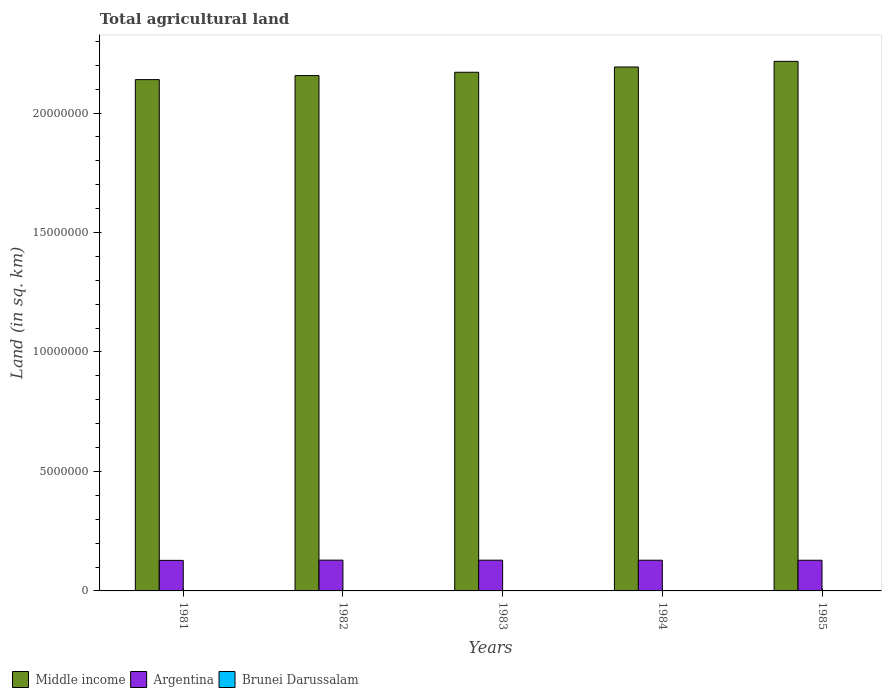How many groups of bars are there?
Offer a very short reply. 5. How many bars are there on the 5th tick from the left?
Ensure brevity in your answer.  3. In how many cases, is the number of bars for a given year not equal to the number of legend labels?
Give a very brief answer. 0. What is the total agricultural land in Argentina in 1985?
Offer a terse response. 1.28e+06. Across all years, what is the maximum total agricultural land in Middle income?
Your answer should be very brief. 2.22e+07. Across all years, what is the minimum total agricultural land in Middle income?
Make the answer very short. 2.14e+07. What is the total total agricultural land in Middle income in the graph?
Ensure brevity in your answer.  1.09e+08. What is the difference between the total agricultural land in Brunei Darussalam in 1982 and that in 1984?
Make the answer very short. 10. What is the difference between the total agricultural land in Argentina in 1982 and the total agricultural land in Brunei Darussalam in 1985?
Your answer should be very brief. 1.29e+06. What is the average total agricultural land in Argentina per year?
Provide a succinct answer. 1.28e+06. In the year 1984, what is the difference between the total agricultural land in Middle income and total agricultural land in Brunei Darussalam?
Offer a terse response. 2.19e+07. Is the total agricultural land in Argentina in 1981 less than that in 1984?
Your answer should be very brief. Yes. What is the difference between the highest and the second highest total agricultural land in Brunei Darussalam?
Offer a terse response. 10. What is the difference between the highest and the lowest total agricultural land in Brunei Darussalam?
Give a very brief answer. 20. In how many years, is the total agricultural land in Middle income greater than the average total agricultural land in Middle income taken over all years?
Give a very brief answer. 2. What does the 2nd bar from the left in 1985 represents?
Make the answer very short. Argentina. Is it the case that in every year, the sum of the total agricultural land in Middle income and total agricultural land in Brunei Darussalam is greater than the total agricultural land in Argentina?
Your response must be concise. Yes. Are all the bars in the graph horizontal?
Ensure brevity in your answer.  No. What is the difference between two consecutive major ticks on the Y-axis?
Provide a short and direct response. 5.00e+06. Are the values on the major ticks of Y-axis written in scientific E-notation?
Offer a very short reply. No. Where does the legend appear in the graph?
Keep it short and to the point. Bottom left. What is the title of the graph?
Provide a succinct answer. Total agricultural land. Does "Paraguay" appear as one of the legend labels in the graph?
Your answer should be compact. No. What is the label or title of the X-axis?
Your response must be concise. Years. What is the label or title of the Y-axis?
Offer a very short reply. Land (in sq. km). What is the Land (in sq. km) in Middle income in 1981?
Your answer should be compact. 2.14e+07. What is the Land (in sq. km) of Argentina in 1981?
Provide a succinct answer. 1.28e+06. What is the Land (in sq. km) in Brunei Darussalam in 1981?
Your response must be concise. 140. What is the Land (in sq. km) of Middle income in 1982?
Your answer should be compact. 2.16e+07. What is the Land (in sq. km) of Argentina in 1982?
Your answer should be compact. 1.29e+06. What is the Land (in sq. km) of Brunei Darussalam in 1982?
Ensure brevity in your answer.  130. What is the Land (in sq. km) of Middle income in 1983?
Offer a terse response. 2.17e+07. What is the Land (in sq. km) in Argentina in 1983?
Provide a short and direct response. 1.29e+06. What is the Land (in sq. km) in Brunei Darussalam in 1983?
Provide a succinct answer. 130. What is the Land (in sq. km) in Middle income in 1984?
Provide a succinct answer. 2.19e+07. What is the Land (in sq. km) in Argentina in 1984?
Your response must be concise. 1.29e+06. What is the Land (in sq. km) in Brunei Darussalam in 1984?
Keep it short and to the point. 120. What is the Land (in sq. km) of Middle income in 1985?
Provide a succinct answer. 2.22e+07. What is the Land (in sq. km) of Argentina in 1985?
Your response must be concise. 1.28e+06. What is the Land (in sq. km) in Brunei Darussalam in 1985?
Ensure brevity in your answer.  120. Across all years, what is the maximum Land (in sq. km) of Middle income?
Offer a very short reply. 2.22e+07. Across all years, what is the maximum Land (in sq. km) of Argentina?
Provide a succinct answer. 1.29e+06. Across all years, what is the maximum Land (in sq. km) of Brunei Darussalam?
Keep it short and to the point. 140. Across all years, what is the minimum Land (in sq. km) in Middle income?
Your response must be concise. 2.14e+07. Across all years, what is the minimum Land (in sq. km) of Argentina?
Provide a succinct answer. 1.28e+06. Across all years, what is the minimum Land (in sq. km) in Brunei Darussalam?
Your response must be concise. 120. What is the total Land (in sq. km) in Middle income in the graph?
Your response must be concise. 1.09e+08. What is the total Land (in sq. km) in Argentina in the graph?
Your answer should be compact. 6.42e+06. What is the total Land (in sq. km) in Brunei Darussalam in the graph?
Provide a succinct answer. 640. What is the difference between the Land (in sq. km) in Middle income in 1981 and that in 1982?
Your answer should be compact. -1.69e+05. What is the difference between the Land (in sq. km) of Argentina in 1981 and that in 1982?
Offer a terse response. -8750. What is the difference between the Land (in sq. km) in Middle income in 1981 and that in 1983?
Provide a succinct answer. -3.08e+05. What is the difference between the Land (in sq. km) in Argentina in 1981 and that in 1983?
Make the answer very short. -7500. What is the difference between the Land (in sq. km) of Brunei Darussalam in 1981 and that in 1983?
Your answer should be very brief. 10. What is the difference between the Land (in sq. km) of Middle income in 1981 and that in 1984?
Your answer should be very brief. -5.28e+05. What is the difference between the Land (in sq. km) of Argentina in 1981 and that in 1984?
Provide a succinct answer. -6230. What is the difference between the Land (in sq. km) of Brunei Darussalam in 1981 and that in 1984?
Give a very brief answer. 20. What is the difference between the Land (in sq. km) of Middle income in 1981 and that in 1985?
Keep it short and to the point. -7.64e+05. What is the difference between the Land (in sq. km) in Argentina in 1981 and that in 1985?
Ensure brevity in your answer.  -4970. What is the difference between the Land (in sq. km) in Brunei Darussalam in 1981 and that in 1985?
Keep it short and to the point. 20. What is the difference between the Land (in sq. km) in Middle income in 1982 and that in 1983?
Your answer should be very brief. -1.39e+05. What is the difference between the Land (in sq. km) of Argentina in 1982 and that in 1983?
Your answer should be compact. 1250. What is the difference between the Land (in sq. km) in Middle income in 1982 and that in 1984?
Provide a succinct answer. -3.59e+05. What is the difference between the Land (in sq. km) in Argentina in 1982 and that in 1984?
Offer a very short reply. 2520. What is the difference between the Land (in sq. km) of Brunei Darussalam in 1982 and that in 1984?
Your response must be concise. 10. What is the difference between the Land (in sq. km) of Middle income in 1982 and that in 1985?
Give a very brief answer. -5.96e+05. What is the difference between the Land (in sq. km) of Argentina in 1982 and that in 1985?
Offer a terse response. 3780. What is the difference between the Land (in sq. km) of Middle income in 1983 and that in 1984?
Provide a short and direct response. -2.20e+05. What is the difference between the Land (in sq. km) in Argentina in 1983 and that in 1984?
Offer a terse response. 1270. What is the difference between the Land (in sq. km) of Middle income in 1983 and that in 1985?
Ensure brevity in your answer.  -4.56e+05. What is the difference between the Land (in sq. km) of Argentina in 1983 and that in 1985?
Offer a terse response. 2530. What is the difference between the Land (in sq. km) of Middle income in 1984 and that in 1985?
Your response must be concise. -2.36e+05. What is the difference between the Land (in sq. km) in Argentina in 1984 and that in 1985?
Provide a succinct answer. 1260. What is the difference between the Land (in sq. km) of Middle income in 1981 and the Land (in sq. km) of Argentina in 1982?
Provide a succinct answer. 2.01e+07. What is the difference between the Land (in sq. km) in Middle income in 1981 and the Land (in sq. km) in Brunei Darussalam in 1982?
Keep it short and to the point. 2.14e+07. What is the difference between the Land (in sq. km) of Argentina in 1981 and the Land (in sq. km) of Brunei Darussalam in 1982?
Your response must be concise. 1.28e+06. What is the difference between the Land (in sq. km) in Middle income in 1981 and the Land (in sq. km) in Argentina in 1983?
Your response must be concise. 2.01e+07. What is the difference between the Land (in sq. km) of Middle income in 1981 and the Land (in sq. km) of Brunei Darussalam in 1983?
Ensure brevity in your answer.  2.14e+07. What is the difference between the Land (in sq. km) in Argentina in 1981 and the Land (in sq. km) in Brunei Darussalam in 1983?
Offer a terse response. 1.28e+06. What is the difference between the Land (in sq. km) of Middle income in 1981 and the Land (in sq. km) of Argentina in 1984?
Your answer should be very brief. 2.01e+07. What is the difference between the Land (in sq. km) of Middle income in 1981 and the Land (in sq. km) of Brunei Darussalam in 1984?
Ensure brevity in your answer.  2.14e+07. What is the difference between the Land (in sq. km) of Argentina in 1981 and the Land (in sq. km) of Brunei Darussalam in 1984?
Ensure brevity in your answer.  1.28e+06. What is the difference between the Land (in sq. km) in Middle income in 1981 and the Land (in sq. km) in Argentina in 1985?
Give a very brief answer. 2.01e+07. What is the difference between the Land (in sq. km) of Middle income in 1981 and the Land (in sq. km) of Brunei Darussalam in 1985?
Offer a very short reply. 2.14e+07. What is the difference between the Land (in sq. km) in Argentina in 1981 and the Land (in sq. km) in Brunei Darussalam in 1985?
Keep it short and to the point. 1.28e+06. What is the difference between the Land (in sq. km) of Middle income in 1982 and the Land (in sq. km) of Argentina in 1983?
Provide a succinct answer. 2.03e+07. What is the difference between the Land (in sq. km) of Middle income in 1982 and the Land (in sq. km) of Brunei Darussalam in 1983?
Your response must be concise. 2.16e+07. What is the difference between the Land (in sq. km) of Argentina in 1982 and the Land (in sq. km) of Brunei Darussalam in 1983?
Provide a short and direct response. 1.29e+06. What is the difference between the Land (in sq. km) of Middle income in 1982 and the Land (in sq. km) of Argentina in 1984?
Ensure brevity in your answer.  2.03e+07. What is the difference between the Land (in sq. km) of Middle income in 1982 and the Land (in sq. km) of Brunei Darussalam in 1984?
Provide a short and direct response. 2.16e+07. What is the difference between the Land (in sq. km) in Argentina in 1982 and the Land (in sq. km) in Brunei Darussalam in 1984?
Offer a very short reply. 1.29e+06. What is the difference between the Land (in sq. km) of Middle income in 1982 and the Land (in sq. km) of Argentina in 1985?
Make the answer very short. 2.03e+07. What is the difference between the Land (in sq. km) in Middle income in 1982 and the Land (in sq. km) in Brunei Darussalam in 1985?
Provide a succinct answer. 2.16e+07. What is the difference between the Land (in sq. km) of Argentina in 1982 and the Land (in sq. km) of Brunei Darussalam in 1985?
Offer a terse response. 1.29e+06. What is the difference between the Land (in sq. km) of Middle income in 1983 and the Land (in sq. km) of Argentina in 1984?
Provide a succinct answer. 2.04e+07. What is the difference between the Land (in sq. km) of Middle income in 1983 and the Land (in sq. km) of Brunei Darussalam in 1984?
Ensure brevity in your answer.  2.17e+07. What is the difference between the Land (in sq. km) of Argentina in 1983 and the Land (in sq. km) of Brunei Darussalam in 1984?
Provide a short and direct response. 1.29e+06. What is the difference between the Land (in sq. km) in Middle income in 1983 and the Land (in sq. km) in Argentina in 1985?
Your response must be concise. 2.04e+07. What is the difference between the Land (in sq. km) in Middle income in 1983 and the Land (in sq. km) in Brunei Darussalam in 1985?
Your answer should be very brief. 2.17e+07. What is the difference between the Land (in sq. km) in Argentina in 1983 and the Land (in sq. km) in Brunei Darussalam in 1985?
Keep it short and to the point. 1.29e+06. What is the difference between the Land (in sq. km) in Middle income in 1984 and the Land (in sq. km) in Argentina in 1985?
Make the answer very short. 2.06e+07. What is the difference between the Land (in sq. km) in Middle income in 1984 and the Land (in sq. km) in Brunei Darussalam in 1985?
Your response must be concise. 2.19e+07. What is the difference between the Land (in sq. km) of Argentina in 1984 and the Land (in sq. km) of Brunei Darussalam in 1985?
Your answer should be very brief. 1.29e+06. What is the average Land (in sq. km) in Middle income per year?
Provide a short and direct response. 2.18e+07. What is the average Land (in sq. km) of Argentina per year?
Ensure brevity in your answer.  1.28e+06. What is the average Land (in sq. km) in Brunei Darussalam per year?
Offer a very short reply. 128. In the year 1981, what is the difference between the Land (in sq. km) of Middle income and Land (in sq. km) of Argentina?
Provide a short and direct response. 2.01e+07. In the year 1981, what is the difference between the Land (in sq. km) of Middle income and Land (in sq. km) of Brunei Darussalam?
Your response must be concise. 2.14e+07. In the year 1981, what is the difference between the Land (in sq. km) of Argentina and Land (in sq. km) of Brunei Darussalam?
Offer a very short reply. 1.28e+06. In the year 1982, what is the difference between the Land (in sq. km) in Middle income and Land (in sq. km) in Argentina?
Your answer should be compact. 2.03e+07. In the year 1982, what is the difference between the Land (in sq. km) in Middle income and Land (in sq. km) in Brunei Darussalam?
Provide a short and direct response. 2.16e+07. In the year 1982, what is the difference between the Land (in sq. km) of Argentina and Land (in sq. km) of Brunei Darussalam?
Offer a very short reply. 1.29e+06. In the year 1983, what is the difference between the Land (in sq. km) of Middle income and Land (in sq. km) of Argentina?
Ensure brevity in your answer.  2.04e+07. In the year 1983, what is the difference between the Land (in sq. km) of Middle income and Land (in sq. km) of Brunei Darussalam?
Make the answer very short. 2.17e+07. In the year 1983, what is the difference between the Land (in sq. km) of Argentina and Land (in sq. km) of Brunei Darussalam?
Provide a short and direct response. 1.29e+06. In the year 1984, what is the difference between the Land (in sq. km) of Middle income and Land (in sq. km) of Argentina?
Your response must be concise. 2.06e+07. In the year 1984, what is the difference between the Land (in sq. km) in Middle income and Land (in sq. km) in Brunei Darussalam?
Your answer should be compact. 2.19e+07. In the year 1984, what is the difference between the Land (in sq. km) of Argentina and Land (in sq. km) of Brunei Darussalam?
Ensure brevity in your answer.  1.29e+06. In the year 1985, what is the difference between the Land (in sq. km) in Middle income and Land (in sq. km) in Argentina?
Offer a very short reply. 2.09e+07. In the year 1985, what is the difference between the Land (in sq. km) in Middle income and Land (in sq. km) in Brunei Darussalam?
Give a very brief answer. 2.22e+07. In the year 1985, what is the difference between the Land (in sq. km) in Argentina and Land (in sq. km) in Brunei Darussalam?
Provide a succinct answer. 1.28e+06. What is the ratio of the Land (in sq. km) of Middle income in 1981 to that in 1983?
Make the answer very short. 0.99. What is the ratio of the Land (in sq. km) of Argentina in 1981 to that in 1983?
Provide a short and direct response. 0.99. What is the ratio of the Land (in sq. km) of Middle income in 1981 to that in 1984?
Give a very brief answer. 0.98. What is the ratio of the Land (in sq. km) of Middle income in 1981 to that in 1985?
Make the answer very short. 0.97. What is the ratio of the Land (in sq. km) in Argentina in 1981 to that in 1985?
Keep it short and to the point. 1. What is the ratio of the Land (in sq. km) of Middle income in 1982 to that in 1983?
Ensure brevity in your answer.  0.99. What is the ratio of the Land (in sq. km) of Middle income in 1982 to that in 1984?
Your answer should be compact. 0.98. What is the ratio of the Land (in sq. km) in Argentina in 1982 to that in 1984?
Ensure brevity in your answer.  1. What is the ratio of the Land (in sq. km) of Brunei Darussalam in 1982 to that in 1984?
Your response must be concise. 1.08. What is the ratio of the Land (in sq. km) in Middle income in 1982 to that in 1985?
Your answer should be compact. 0.97. What is the ratio of the Land (in sq. km) in Argentina in 1982 to that in 1985?
Your answer should be compact. 1. What is the ratio of the Land (in sq. km) in Brunei Darussalam in 1982 to that in 1985?
Keep it short and to the point. 1.08. What is the ratio of the Land (in sq. km) of Middle income in 1983 to that in 1985?
Your answer should be compact. 0.98. What is the ratio of the Land (in sq. km) in Argentina in 1983 to that in 1985?
Your response must be concise. 1. What is the ratio of the Land (in sq. km) in Middle income in 1984 to that in 1985?
Ensure brevity in your answer.  0.99. What is the ratio of the Land (in sq. km) in Argentina in 1984 to that in 1985?
Your answer should be compact. 1. What is the ratio of the Land (in sq. km) in Brunei Darussalam in 1984 to that in 1985?
Keep it short and to the point. 1. What is the difference between the highest and the second highest Land (in sq. km) in Middle income?
Your answer should be very brief. 2.36e+05. What is the difference between the highest and the second highest Land (in sq. km) of Argentina?
Provide a short and direct response. 1250. What is the difference between the highest and the lowest Land (in sq. km) in Middle income?
Give a very brief answer. 7.64e+05. What is the difference between the highest and the lowest Land (in sq. km) in Argentina?
Provide a short and direct response. 8750. What is the difference between the highest and the lowest Land (in sq. km) of Brunei Darussalam?
Your answer should be very brief. 20. 